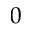<formula> <loc_0><loc_0><loc_500><loc_500>0</formula> 